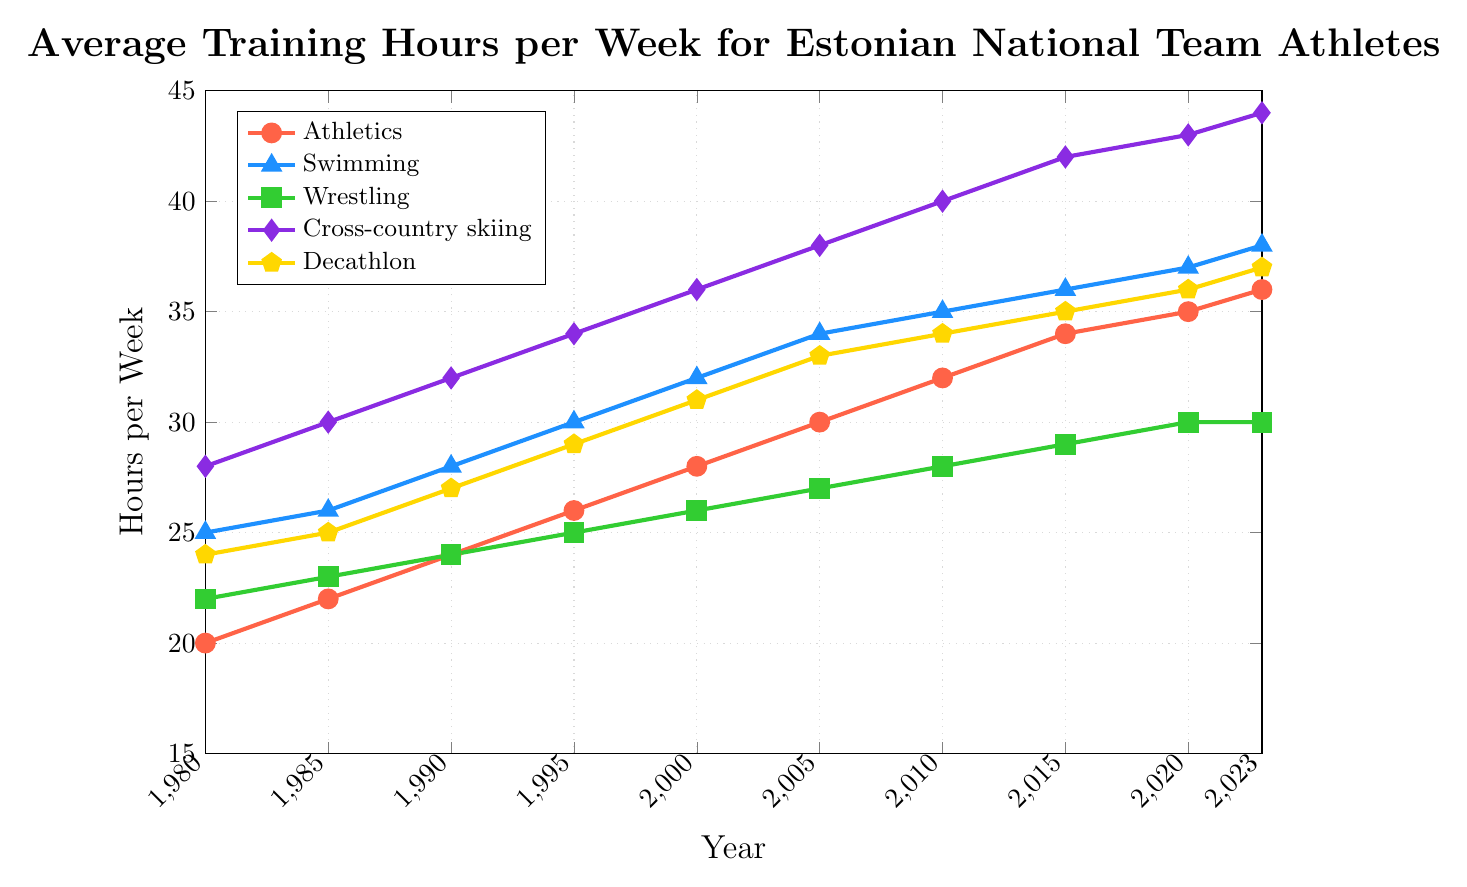What's the average training hours per week for Athletics in 2000 and 2010? To find the average, sum the values for 2000 and 2010 and then divide by the number of data points. (28 + 32) / 2 = 60 / 2 = 30
Answer: 30 Which sport had the highest training hours per week in 1980? By comparing the training hours for each sport in 1980, the highest value is found in Cross-country skiing with 28 hours per week.
Answer: Cross-country skiing How much did the training hours for Swimming increase from 1980 to 2023? Subtract the value in 1980 from the value in 2023 for Swimming. 38 - 25 = 13
Answer: 13 Which sports showed a constant increase in training hours per week from 1980 to 2023? By examining the plotted lines, Athletics, Swimming, Cross-country skiing, and Decathlon all show a constant increase in training hours per week. Wrestling only increased until 2020 and then stayed the same until 2023.
Answer: Athletics, Swimming, Cross-country skiing, Decathlon In which year did Decathlon surpass Athletics in training hours per week? By analyzing the years and comparing the values for Decathlon and Athletics, Decathlon surpassed Athletics between 1985 and 1990.
Answer: 1990 What is the difference in training hours per week between Cross-country skiing and Wrestling in 2023? Subtract the value of Wrestling from the value of Cross-country skiing in 2023. 44 - 30 = 14
Answer: 14 Which sport had the least increase in training hours per week from 1980 to 2023? By examining the increase for each sport from 1980 to 2023, Wrestling had the least increase (30 - 22 = 8).
Answer: Wrestling What is the visual color representation for Swimming? By examining the plot legend, Swimming is represented by the color blue.
Answer: Blue How many more hours per week did Cross-country skiing have compared to Decathlon in 2005? Subtract the value for Decathlon from the value for Cross-country skiing in 2005. 38 - 33 = 5
Answer: 5 What is the overall trend observed in the training hours per week for all sports? By looking at the graph, all sports show an increasing trend in training hours per week from 1980 to 2023.
Answer: Increasing 